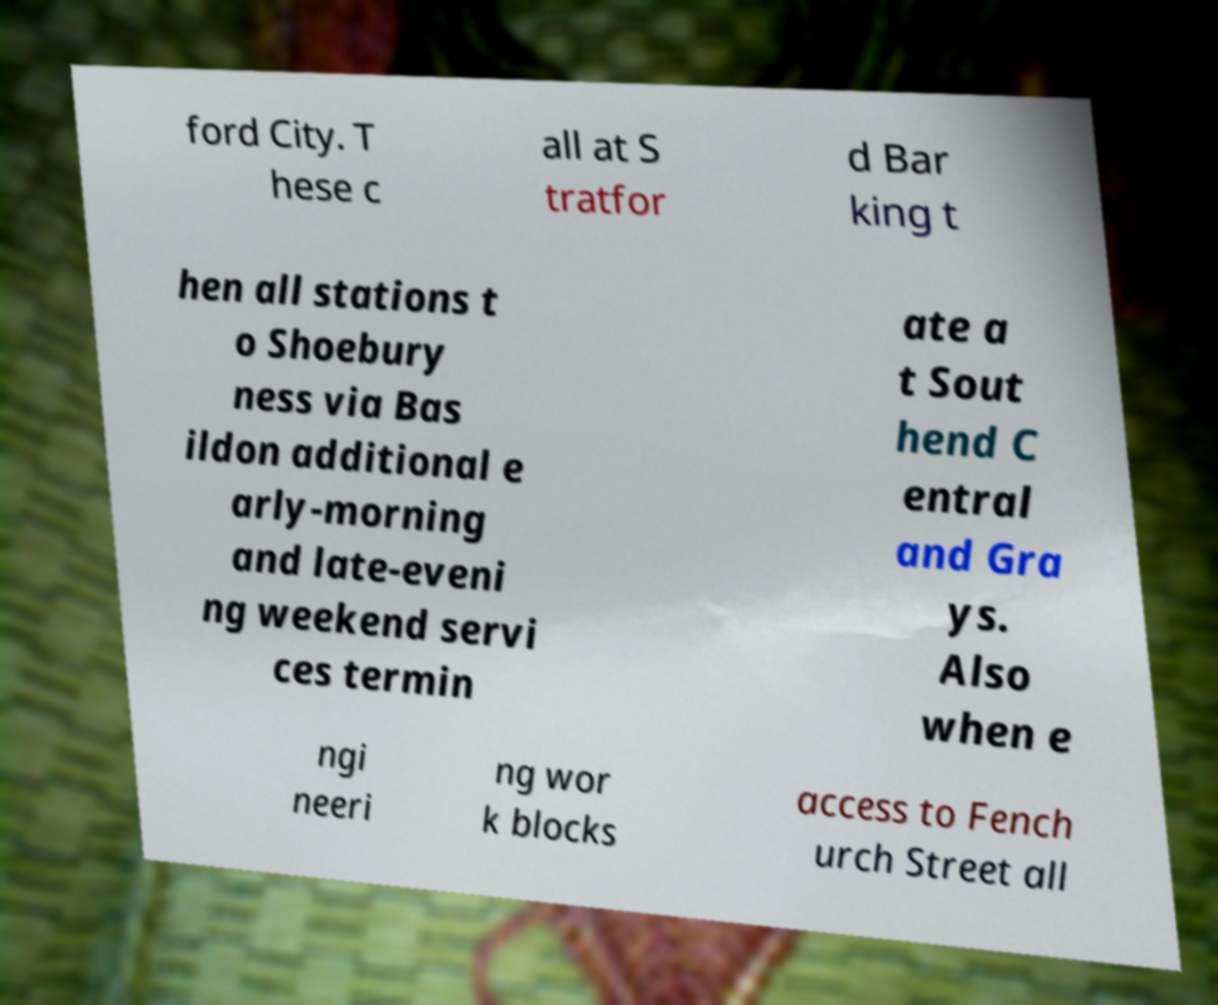Can you accurately transcribe the text from the provided image for me? ford City. T hese c all at S tratfor d Bar king t hen all stations t o Shoebury ness via Bas ildon additional e arly-morning and late-eveni ng weekend servi ces termin ate a t Sout hend C entral and Gra ys. Also when e ngi neeri ng wor k blocks access to Fench urch Street all 